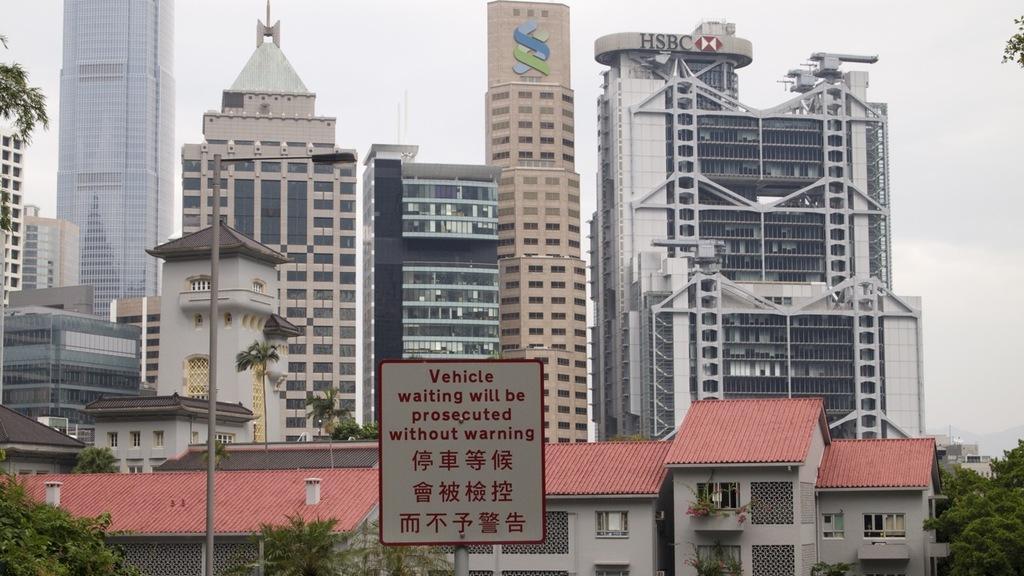How would you summarize this image in a sentence or two? In this image I can see two poles in the front and on one pole I can see a white colour board. I can also see something is written on the board. In the background I can see number of buildings, trees and the sky. On the top side of this image I can see something is written on the building. 